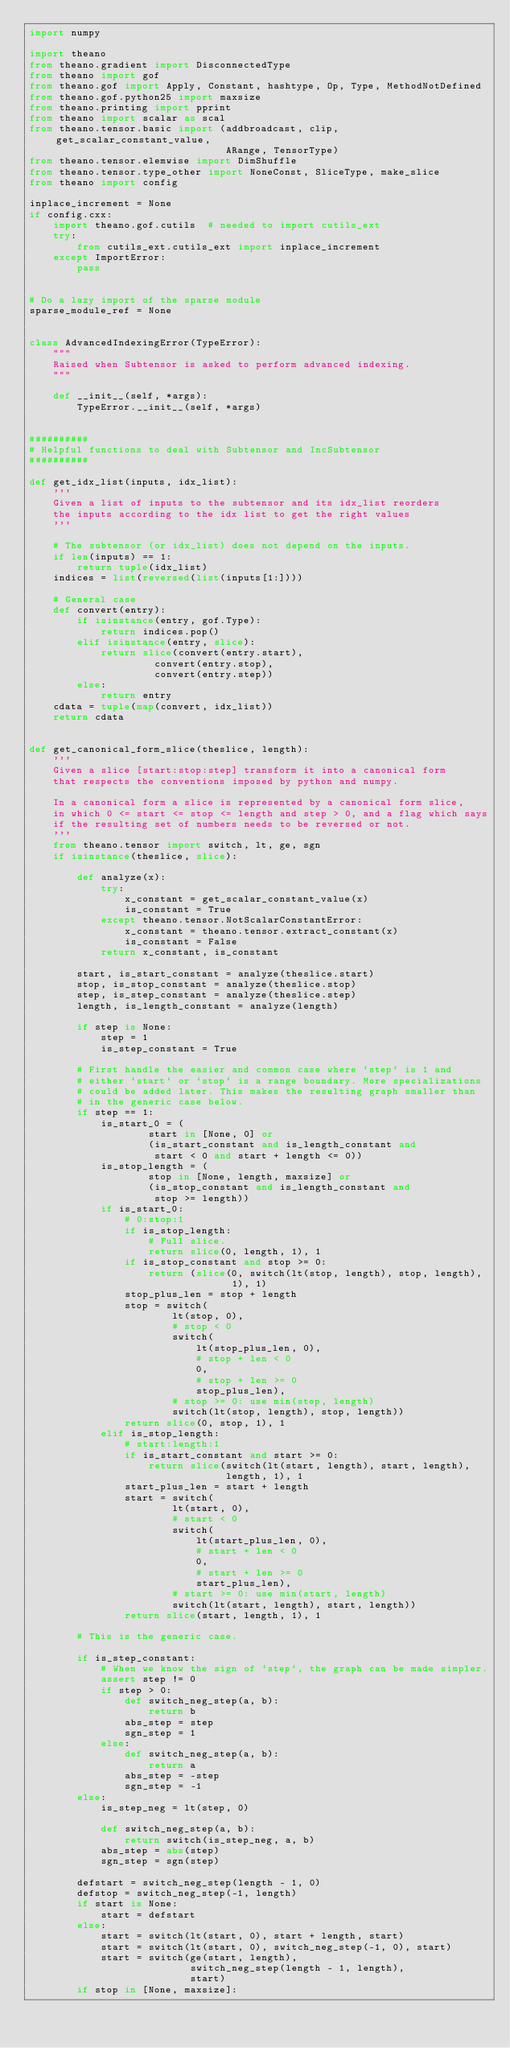<code> <loc_0><loc_0><loc_500><loc_500><_Python_>import numpy

import theano
from theano.gradient import DisconnectedType
from theano import gof
from theano.gof import Apply, Constant, hashtype, Op, Type, MethodNotDefined
from theano.gof.python25 import maxsize
from theano.printing import pprint
from theano import scalar as scal
from theano.tensor.basic import (addbroadcast, clip, get_scalar_constant_value,
                                 ARange, TensorType)
from theano.tensor.elemwise import DimShuffle
from theano.tensor.type_other import NoneConst, SliceType, make_slice
from theano import config

inplace_increment = None
if config.cxx:
    import theano.gof.cutils  # needed to import cutils_ext
    try:
        from cutils_ext.cutils_ext import inplace_increment
    except ImportError:
        pass


# Do a lazy import of the sparse module
sparse_module_ref = None


class AdvancedIndexingError(TypeError):
    """
    Raised when Subtensor is asked to perform advanced indexing.
    """

    def __init__(self, *args):
        TypeError.__init__(self, *args)


##########
# Helpful functions to deal with Subtensor and IncSubtensor
##########

def get_idx_list(inputs, idx_list):
    '''
    Given a list of inputs to the subtensor and its idx_list reorders
    the inputs according to the idx list to get the right values
    '''

    # The subtensor (or idx_list) does not depend on the inputs.
    if len(inputs) == 1:
        return tuple(idx_list)
    indices = list(reversed(list(inputs[1:])))

    # General case
    def convert(entry):
        if isinstance(entry, gof.Type):
            return indices.pop()
        elif isinstance(entry, slice):
            return slice(convert(entry.start),
                     convert(entry.stop),
                     convert(entry.step))
        else:
            return entry
    cdata = tuple(map(convert, idx_list))
    return cdata


def get_canonical_form_slice(theslice, length):
    '''
    Given a slice [start:stop:step] transform it into a canonical form
    that respects the conventions imposed by python and numpy.

    In a canonical form a slice is represented by a canonical form slice,
    in which 0 <= start <= stop <= length and step > 0, and a flag which says
    if the resulting set of numbers needs to be reversed or not.
    '''
    from theano.tensor import switch, lt, ge, sgn
    if isinstance(theslice, slice):

        def analyze(x):
            try:
                x_constant = get_scalar_constant_value(x)
                is_constant = True
            except theano.tensor.NotScalarConstantError:
                x_constant = theano.tensor.extract_constant(x)
                is_constant = False
            return x_constant, is_constant

        start, is_start_constant = analyze(theslice.start)
        stop, is_stop_constant = analyze(theslice.stop)
        step, is_step_constant = analyze(theslice.step)
        length, is_length_constant = analyze(length)

        if step is None:
            step = 1
            is_step_constant = True

        # First handle the easier and common case where `step` is 1 and
        # either `start` or `stop` is a range boundary. More specializations
        # could be added later. This makes the resulting graph smaller than
        # in the generic case below.
        if step == 1:
            is_start_0 = (
                    start in [None, 0] or
                    (is_start_constant and is_length_constant and
                     start < 0 and start + length <= 0))
            is_stop_length = (
                    stop in [None, length, maxsize] or
                    (is_stop_constant and is_length_constant and
                     stop >= length))
            if is_start_0:
                # 0:stop:1
                if is_stop_length:
                    # Full slice.
                    return slice(0, length, 1), 1
                if is_stop_constant and stop >= 0:
                    return (slice(0, switch(lt(stop, length), stop, length),
                                  1), 1)
                stop_plus_len = stop + length
                stop = switch(
                        lt(stop, 0),
                        # stop < 0
                        switch(
                            lt(stop_plus_len, 0),
                            # stop + len < 0
                            0,
                            # stop + len >= 0
                            stop_plus_len),
                        # stop >= 0: use min(stop, length)
                        switch(lt(stop, length), stop, length))
                return slice(0, stop, 1), 1
            elif is_stop_length:
                # start:length:1
                if is_start_constant and start >= 0:
                    return slice(switch(lt(start, length), start, length),
                                 length, 1), 1
                start_plus_len = start + length
                start = switch(
                        lt(start, 0),
                        # start < 0
                        switch(
                            lt(start_plus_len, 0),
                            # start + len < 0
                            0,
                            # start + len >= 0
                            start_plus_len),
                        # start >= 0: use min(start, length)
                        switch(lt(start, length), start, length))
                return slice(start, length, 1), 1

        # This is the generic case.

        if is_step_constant:
            # When we know the sign of `step`, the graph can be made simpler.
            assert step != 0
            if step > 0:
                def switch_neg_step(a, b):
                    return b
                abs_step = step
                sgn_step = 1
            else:
                def switch_neg_step(a, b):
                    return a
                abs_step = -step
                sgn_step = -1
        else:
            is_step_neg = lt(step, 0)

            def switch_neg_step(a, b):
                return switch(is_step_neg, a, b)
            abs_step = abs(step)
            sgn_step = sgn(step)

        defstart = switch_neg_step(length - 1, 0)
        defstop = switch_neg_step(-1, length)
        if start is None:
            start = defstart
        else:
            start = switch(lt(start, 0), start + length, start)
            start = switch(lt(start, 0), switch_neg_step(-1, 0), start)
            start = switch(ge(start, length),
                           switch_neg_step(length - 1, length),
                           start)
        if stop in [None, maxsize]:</code> 